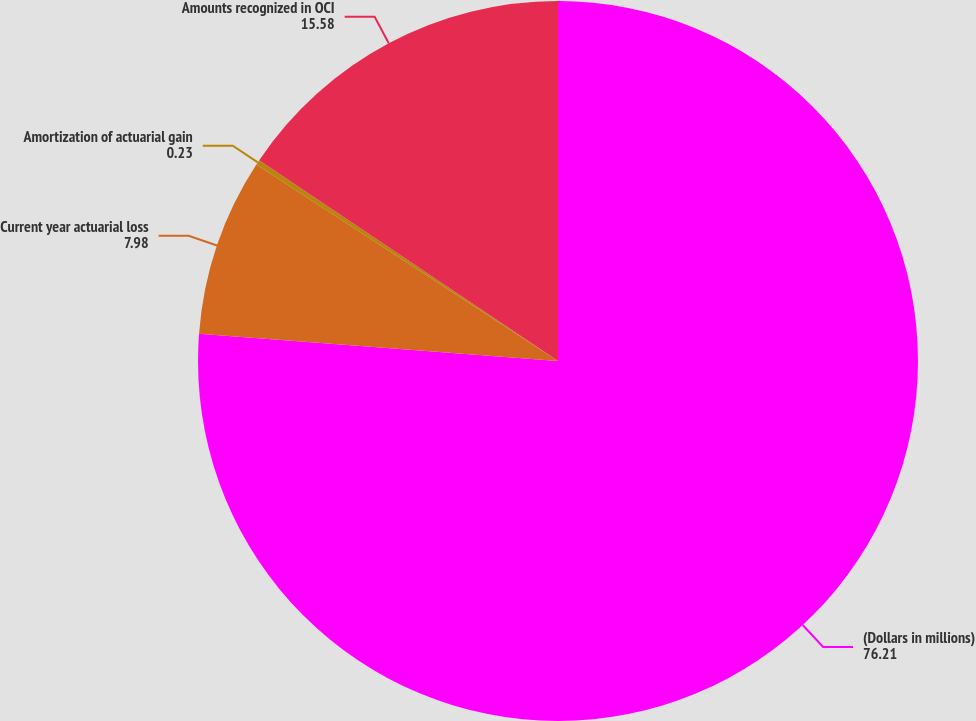Convert chart to OTSL. <chart><loc_0><loc_0><loc_500><loc_500><pie_chart><fcel>(Dollars in millions)<fcel>Current year actuarial loss<fcel>Amortization of actuarial gain<fcel>Amounts recognized in OCI<nl><fcel>76.21%<fcel>7.98%<fcel>0.23%<fcel>15.58%<nl></chart> 